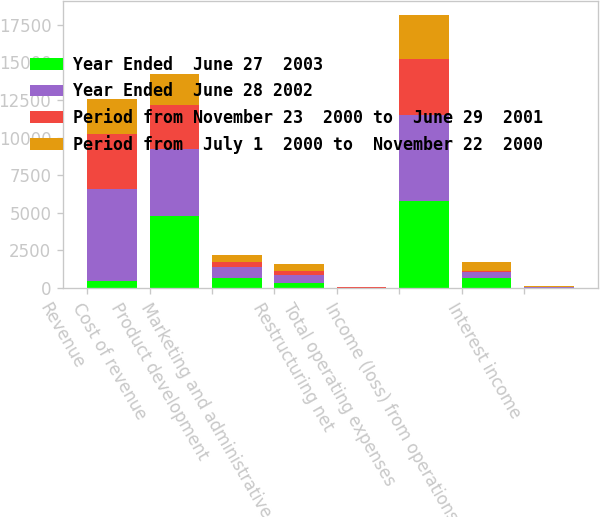Convert chart to OTSL. <chart><loc_0><loc_0><loc_500><loc_500><stacked_bar_chart><ecel><fcel>Revenue<fcel>Cost of revenue<fcel>Product development<fcel>Marketing and administrative<fcel>Restructuring net<fcel>Total operating expenses<fcel>Income (loss) from operations<fcel>Interest income<nl><fcel>Year Ended  June 27  2003<fcel>498<fcel>4759<fcel>670<fcel>357<fcel>9<fcel>5795<fcel>691<fcel>16<nl><fcel>Year Ended  June 28 2002<fcel>6087<fcel>4494<fcel>698<fcel>498<fcel>4<fcel>5713<fcel>374<fcel>25<nl><fcel>Period from November 23  2000 to  June 29  2001<fcel>3656<fcel>2924<fcel>388<fcel>288<fcel>66<fcel>3730<fcel>74<fcel>31<nl><fcel>Period from  July 1  2000 to  November 22  2000<fcel>2310<fcel>2035<fcel>409<fcel>450<fcel>19<fcel>2933<fcel>623<fcel>57<nl></chart> 